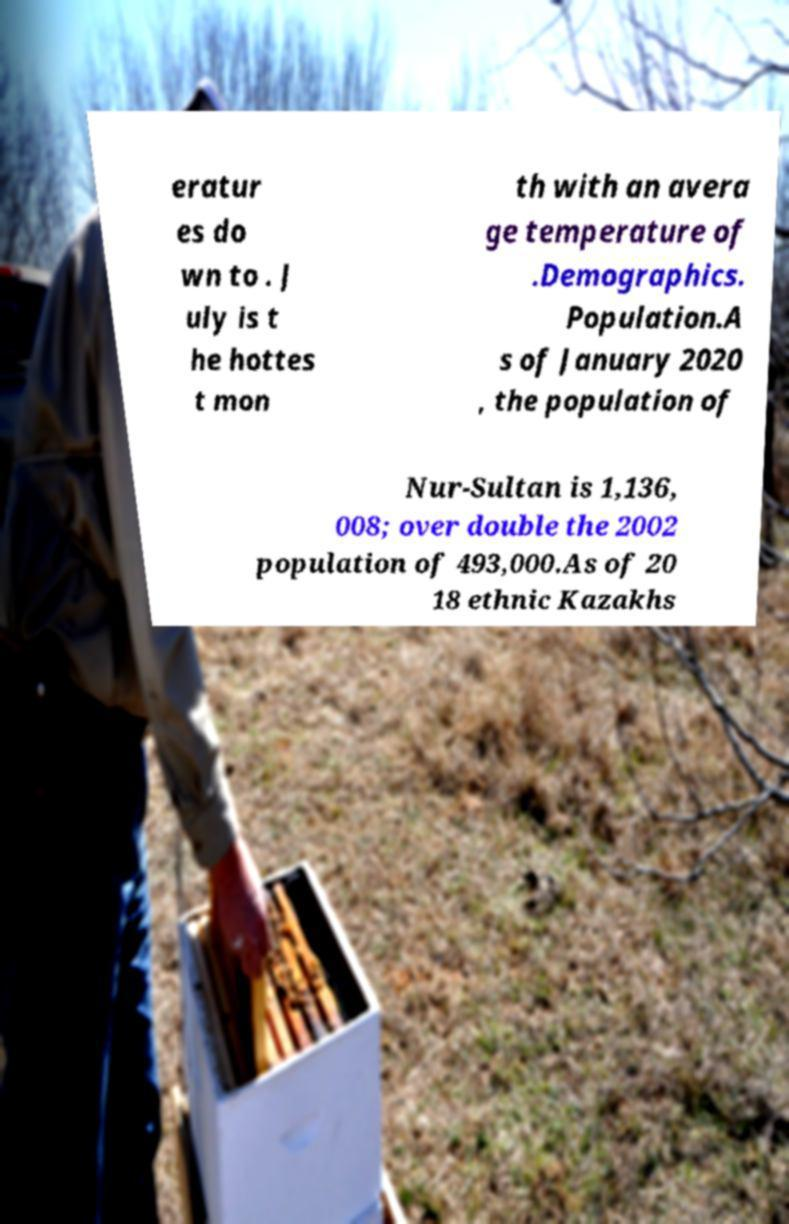Could you extract and type out the text from this image? eratur es do wn to . J uly is t he hottes t mon th with an avera ge temperature of .Demographics. Population.A s of January 2020 , the population of Nur-Sultan is 1,136, 008; over double the 2002 population of 493,000.As of 20 18 ethnic Kazakhs 